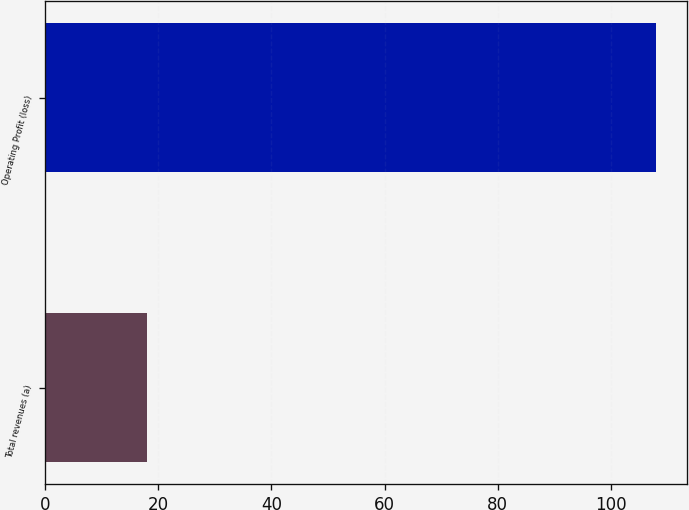<chart> <loc_0><loc_0><loc_500><loc_500><bar_chart><fcel>Total revenues (a)<fcel>Operating Profit (loss)<nl><fcel>18<fcel>108<nl></chart> 